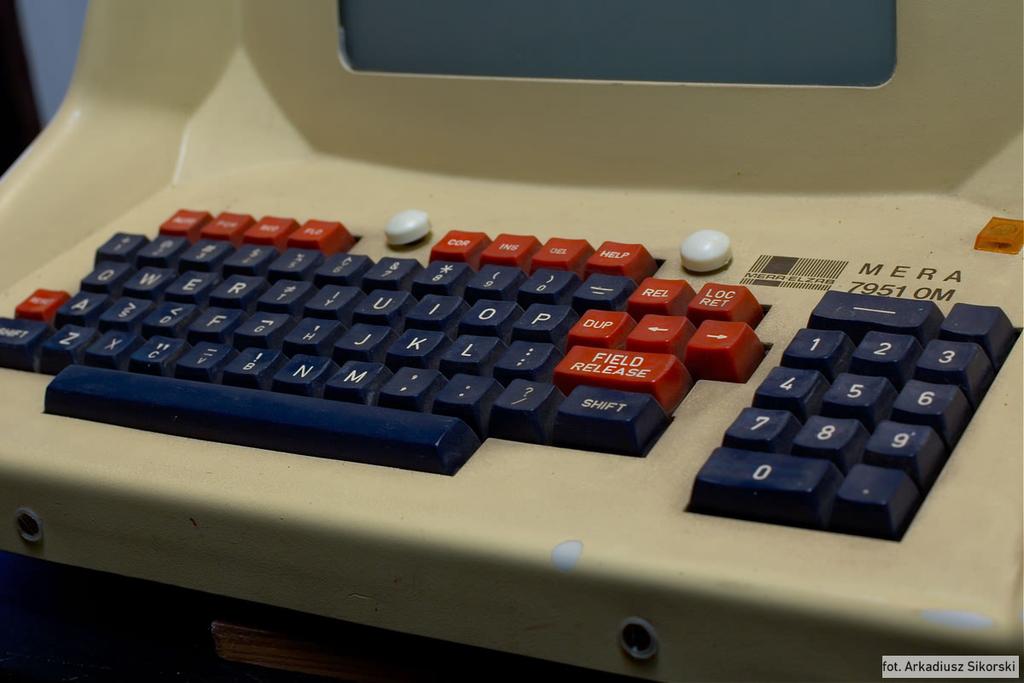What is the computer name?
Ensure brevity in your answer.  Mera. Is there a "field release" button?
Provide a succinct answer. Yes. 